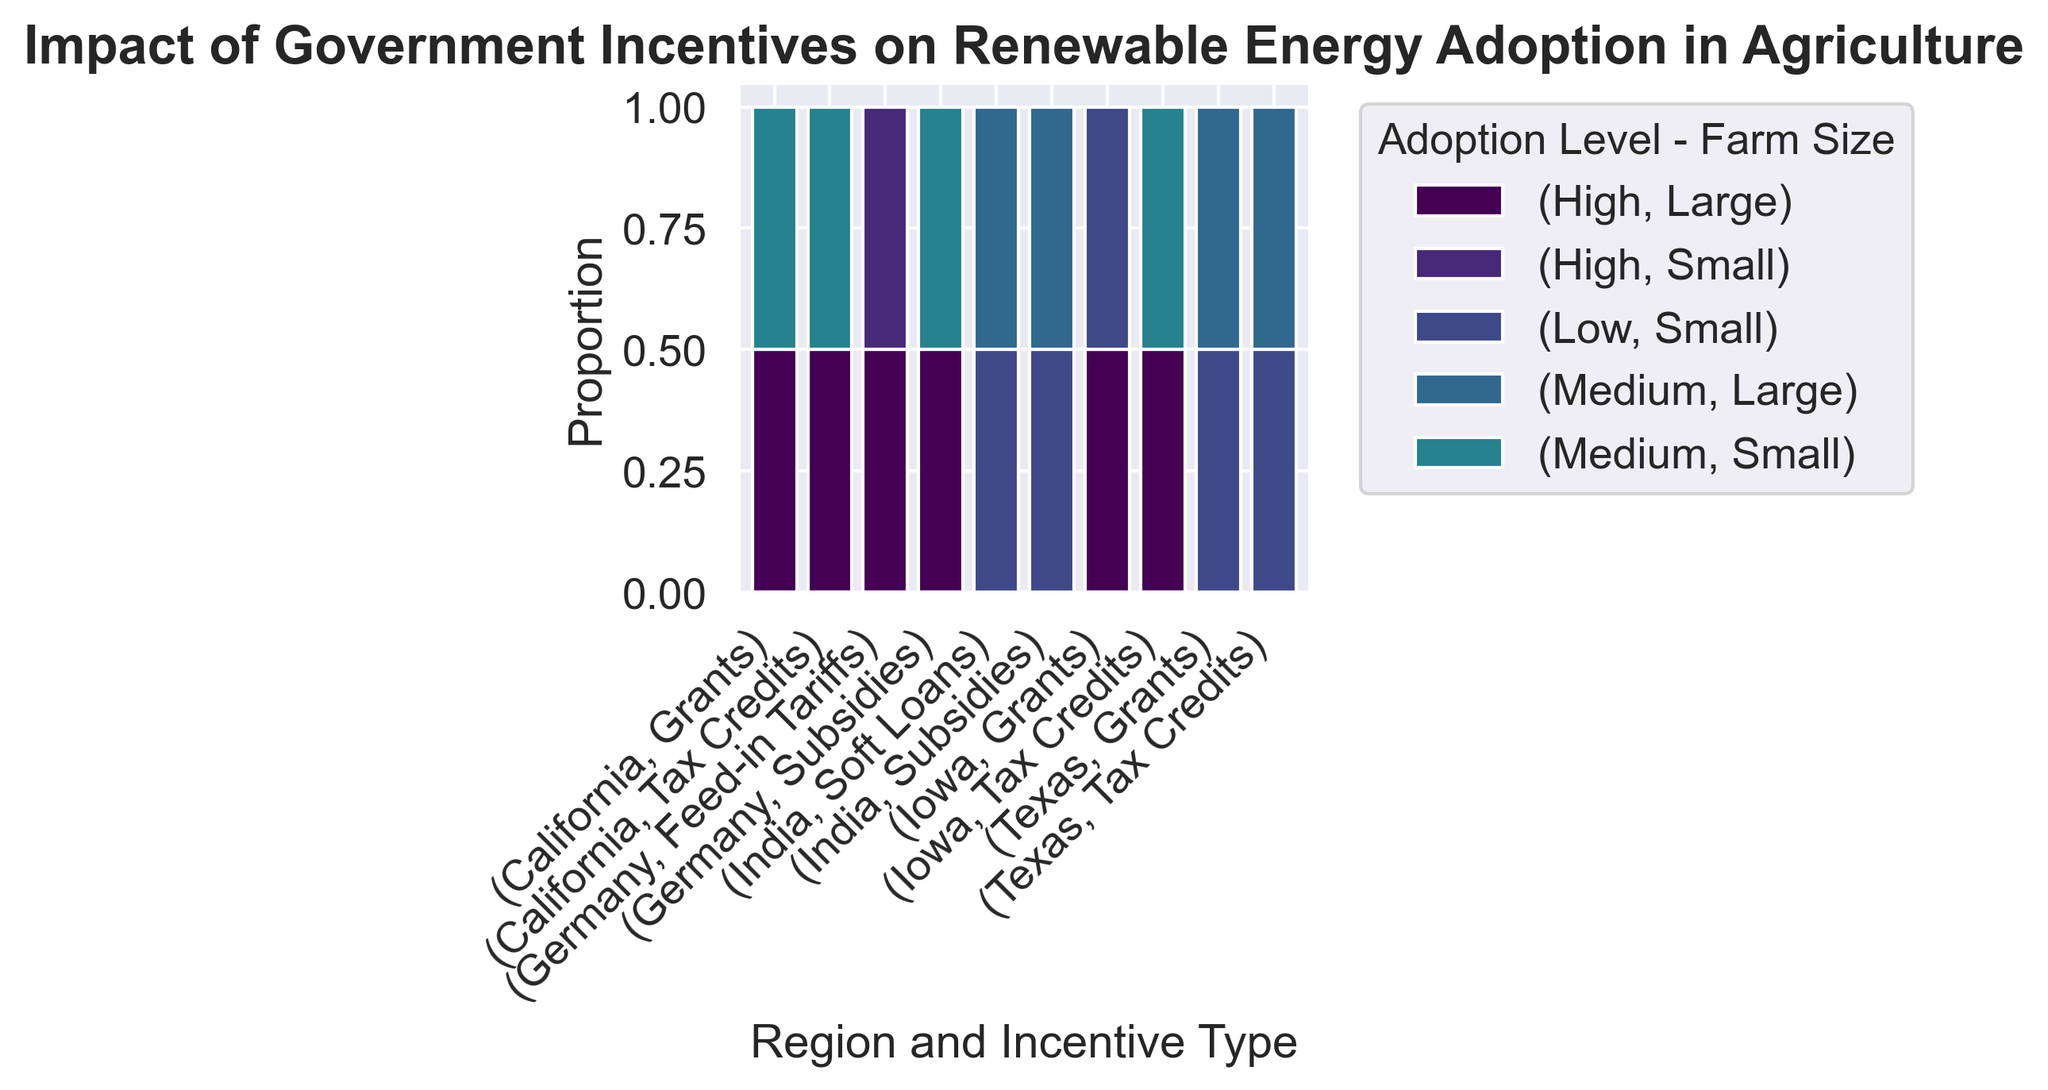What regions are represented in the plot? The x-axis categories represent different regions along with respective incentive types. By looking at the x-axis, we can identify the regions included in the plot.
Answer: California, Texas, Iowa, Germany, India Which region-incentive combination shows the highest proportion of high adoption levels for large farms? Observe the height of the bars for each combination under the category labelled as "High - Large". The tallest bar will indicate the highest proportion.
Answer: Germany-Feed-in Tariffs Which region-incentive combination has the lowest proportion of renewable energy adoption? Look for the combination with the smallest bar height overall. All the smaller "Medium-Large" and "Low-Small" bars should also be considered.
Answer: Texas-Grants Are tax credits more effective in California or Iowa for high adoption levels at large farm sizes? Compare the height of the bars for the "High - Large" category between California and Iowa under the Tax Credits incentive type.
Answer: Iowa What is the proportion of medium adoption levels in Texas with tax credits for large farms? Identify the height of the bar for "Medium - Large" in Texas under the Tax Credits incentive type. This gives the proportion.
Answer: Very small, almost negligible Does any region show equally high adoption levels for small and large farms using the same incentive type? Examine the bars in the "High" adoption level for both "Small" and "Large" farms in each incentive type to see if there's an equal proportion.
Answer: Germany-Feed-in Tariffs Which region shows the highest diversity in adoption levels for grants? Check the variation in bar heights under Grants for each region. The highest diversity is represented by more varied bar heights.
Answer: California Are soft loans in India more effective for larger or smaller farms? Compare the height of the bars under Soft Loans for both "Medium - Large" and "Low - Small" in India.
Answer: Larger farms How does the adoption level for subsidies in India compare between small and large farms? Check the bar heights under the Subsidies incentive in India for the categories "Medium - Large" and "Low - Small". Larger heights represent higher proportions.
Answer: Lower for small farms, higher for large farms Which region has the highest overall adoption level for any incentive type? This involves identifying the highest bar across all regions and adding up individual high adoption levels to see the most prominent one.
Answer: Germany-Feed-in Tariffs 